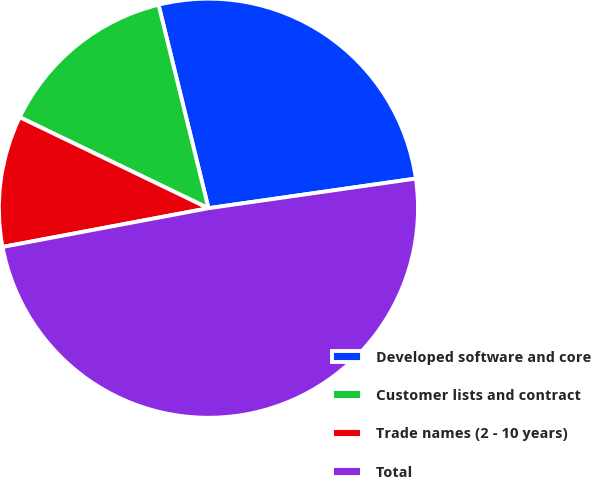Convert chart to OTSL. <chart><loc_0><loc_0><loc_500><loc_500><pie_chart><fcel>Developed software and core<fcel>Customer lists and contract<fcel>Trade names (2 - 10 years)<fcel>Total<nl><fcel>26.57%<fcel>14.02%<fcel>10.11%<fcel>49.3%<nl></chart> 